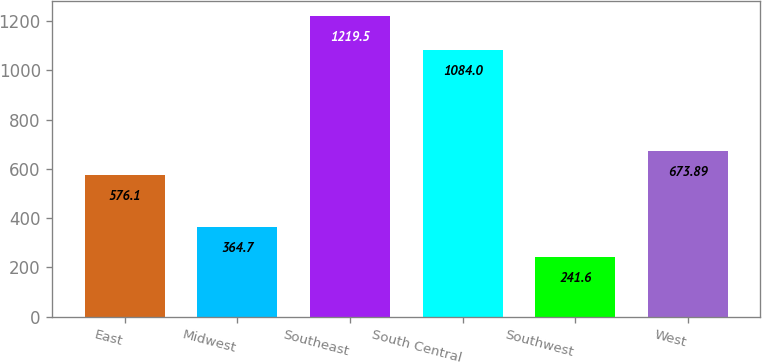<chart> <loc_0><loc_0><loc_500><loc_500><bar_chart><fcel>East<fcel>Midwest<fcel>Southeast<fcel>South Central<fcel>Southwest<fcel>West<nl><fcel>576.1<fcel>364.7<fcel>1219.5<fcel>1084<fcel>241.6<fcel>673.89<nl></chart> 